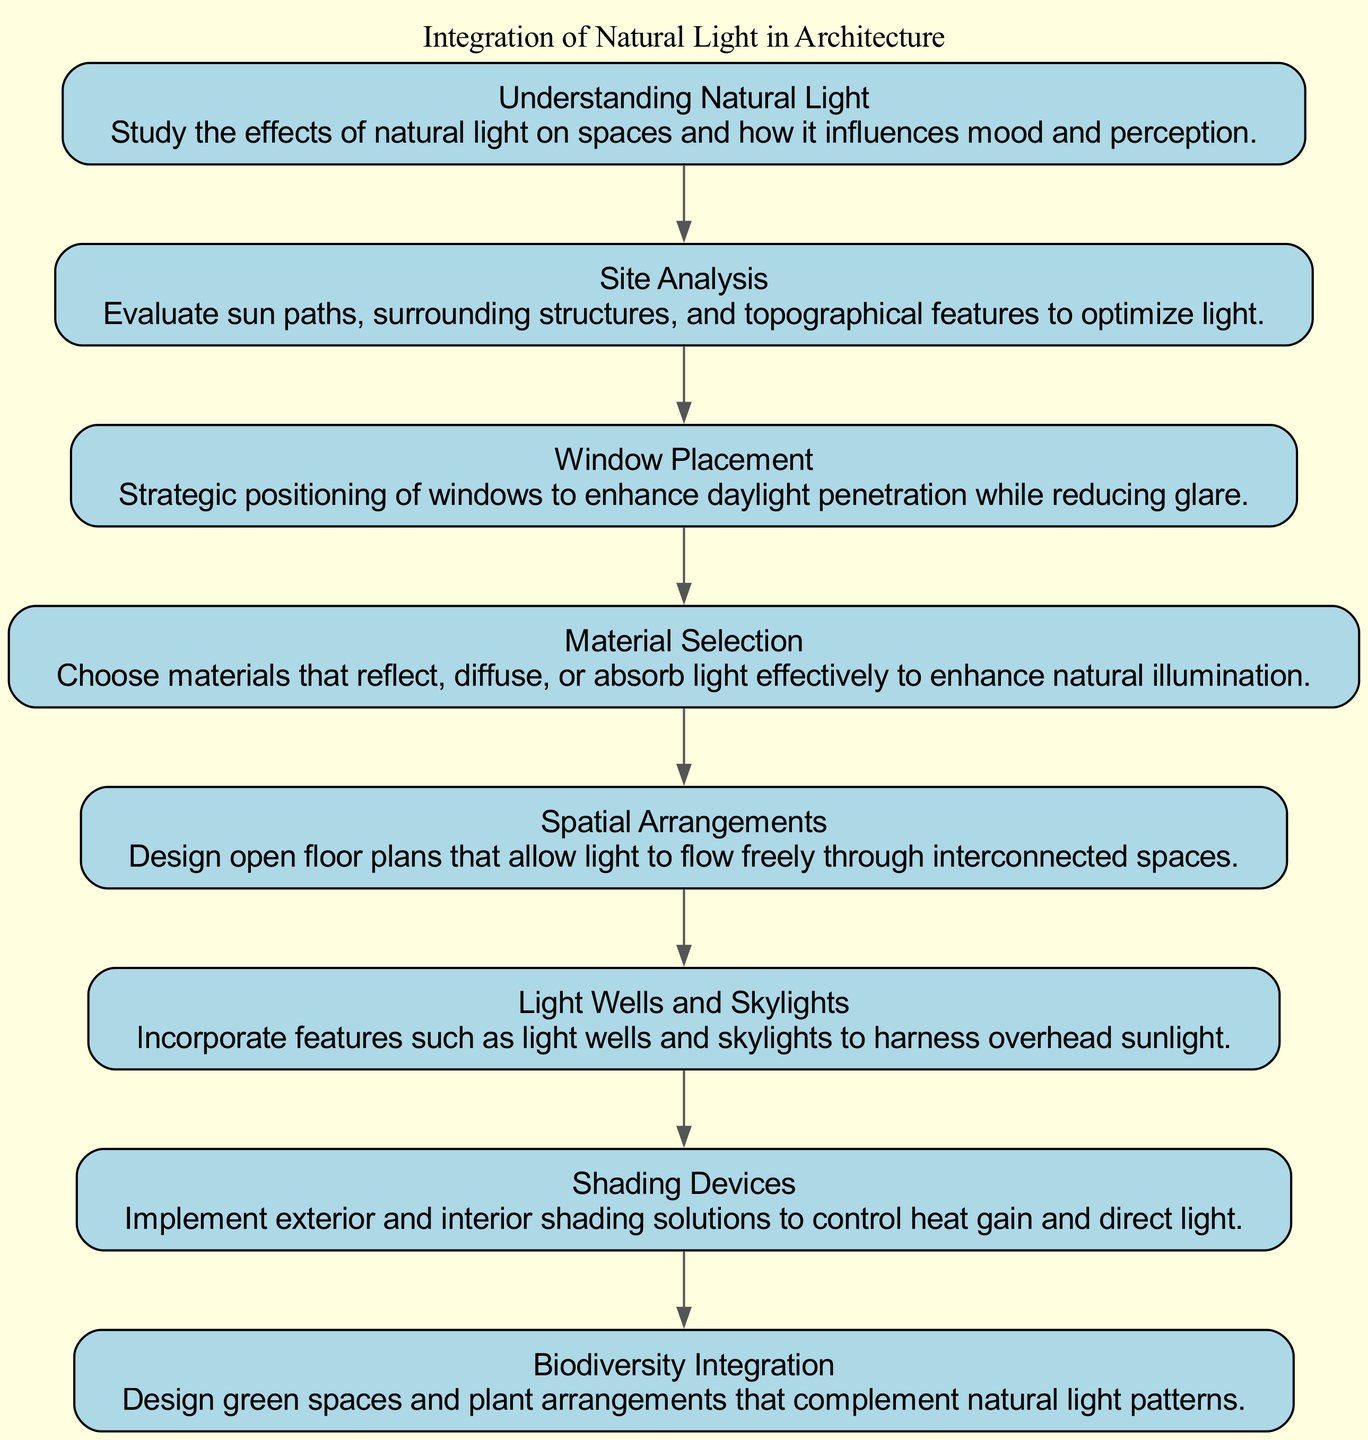What is the first element in the flow chart? The flow chart starts with "Understanding Natural Light," which is identified as the first element. This can be determined by looking at the top part of the diagram where the nodes begin.
Answer: Understanding Natural Light How many total elements are in the flow chart? Counting all the nodes in the flow chart reveals there are eight elements listed from "Understanding Natural Light" to "Biodiversity Integration." This is verified by noting the number of different nodes present in the diagram.
Answer: Eight Which two elements are directly connected? "Site Analysis" is directly connected to "Understanding Natural Light," as shown in the diagram by the edge drawn from the first element to the second element. This can be assessed by checking the arrows indicating direction between the nodes.
Answer: Site Analysis and Understanding Natural Light What element focuses on controlling heat gain? The element "Shading Devices" emphasizes controlling heat gain through the implementation of shading solutions. By locating this element in the flow chart, we can see its focus.
Answer: Shading Devices What purpose does the element "Light Wells and Skylights" serve? The element "Light Wells and Skylights" is intended to harness overhead sunlight, as described in its summary. This can be directly read from the node that contains this information in the diagram.
Answer: Harness overhead sunlight What is the relationship between "Window Placement" and "Material Selection"? "Window Placement" directly precedes "Material Selection" in the flow chart, indicating a sequential relationship where choosing optimal window placements may influence material choices. This relationship is seen clearly through the connecting edge in the diagram.
Answer: Sequential relationship Which element integrates biodiversity into architectural design? The element that integrates biodiversity is "Biodiversity Integration," as it is explicitly stated in its description that it designs green spaces and plant arrangements. This can be directly checked by reading the description from the diagram.
Answer: Biodiversity Integration How many elements focus on enhancing natural light in a building? Five elements focus on the enhancement of natural light: "Understanding Natural Light," "Window Placement," "Material Selection," "Light Wells and Skylights," and "Spatial Arrangements." This is determined by selecting the elements that explicitly deal with natural light integration from the flow chart.
Answer: Five 